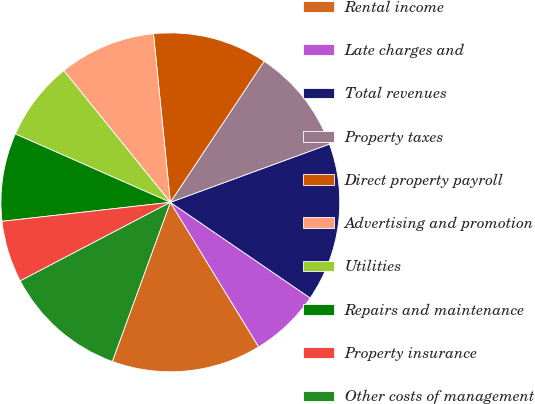Convert chart. <chart><loc_0><loc_0><loc_500><loc_500><pie_chart><fcel>Rental income<fcel>Late charges and<fcel>Total revenues<fcel>Property taxes<fcel>Direct property payroll<fcel>Advertising and promotion<fcel>Utilities<fcel>Repairs and maintenance<fcel>Property insurance<fcel>Other costs of management<nl><fcel>14.29%<fcel>6.72%<fcel>15.13%<fcel>10.08%<fcel>10.92%<fcel>9.24%<fcel>7.56%<fcel>8.4%<fcel>5.88%<fcel>11.76%<nl></chart> 